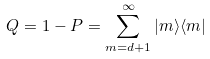<formula> <loc_0><loc_0><loc_500><loc_500>Q = 1 - P = \sum _ { m = d + 1 } ^ { \infty } | m \rangle \langle m |</formula> 